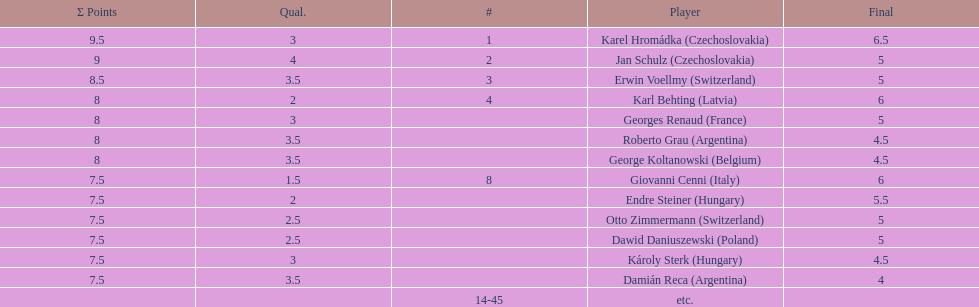Which player had the largest number of &#931; points? Karel Hromádka. 